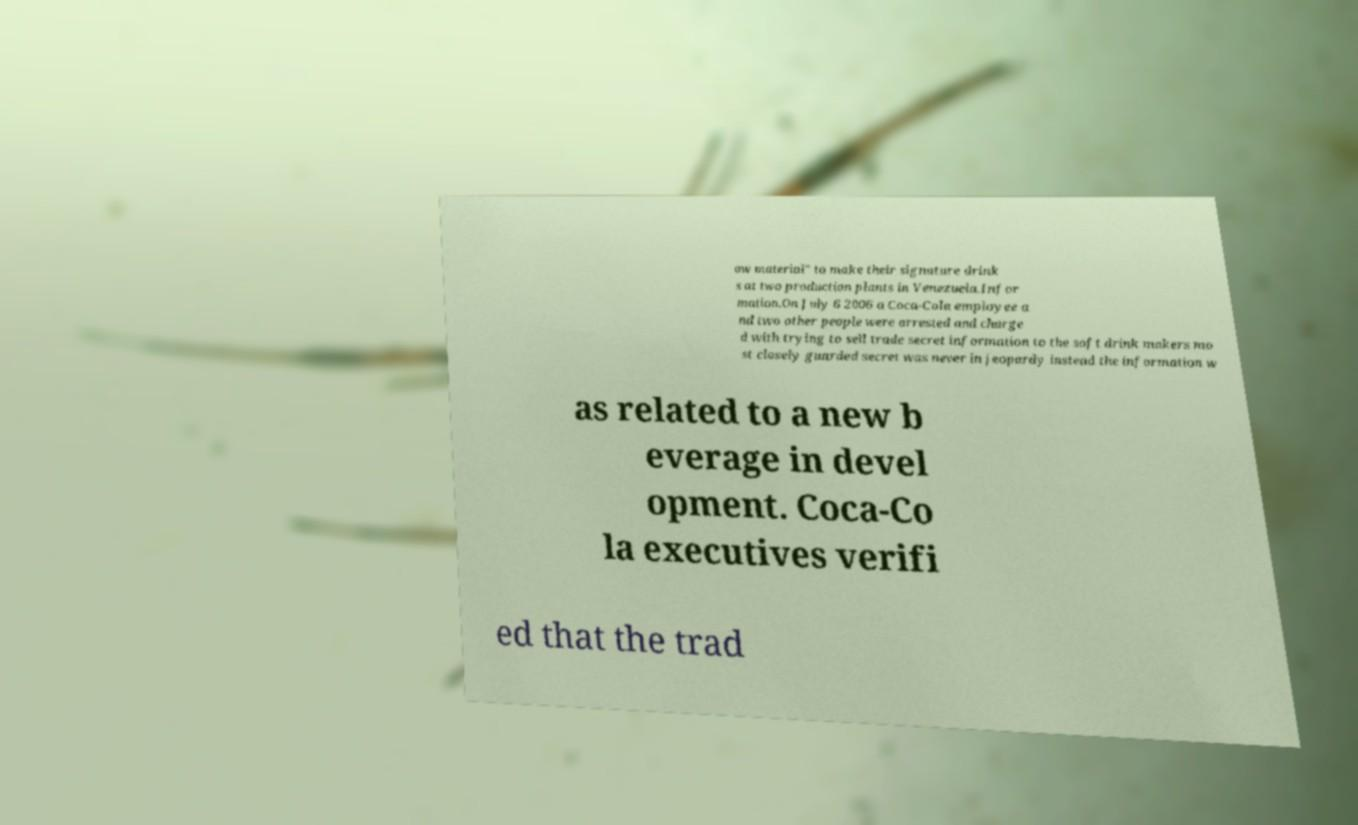Could you assist in decoding the text presented in this image and type it out clearly? aw material" to make their signature drink s at two production plants in Venezuela.Infor mation.On July 6 2006 a Coca-Cola employee a nd two other people were arrested and charge d with trying to sell trade secret information to the soft drink makers mo st closely guarded secret was never in jeopardy instead the information w as related to a new b everage in devel opment. Coca-Co la executives verifi ed that the trad 